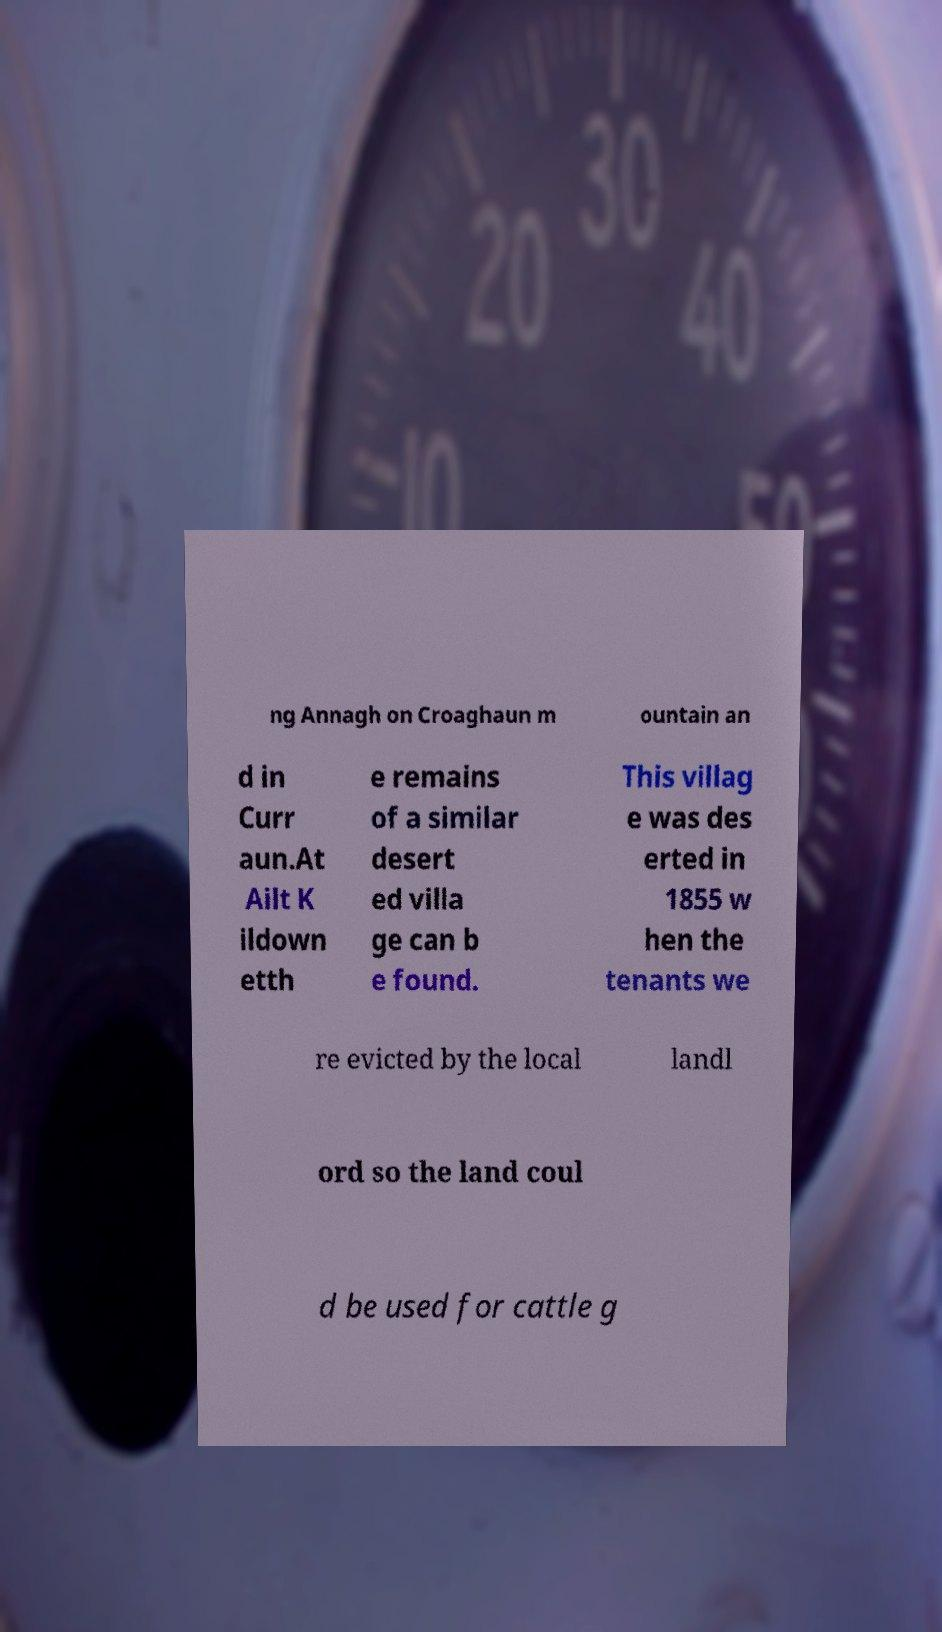I need the written content from this picture converted into text. Can you do that? ng Annagh on Croaghaun m ountain an d in Curr aun.At Ailt K ildown etth e remains of a similar desert ed villa ge can b e found. This villag e was des erted in 1855 w hen the tenants we re evicted by the local landl ord so the land coul d be used for cattle g 